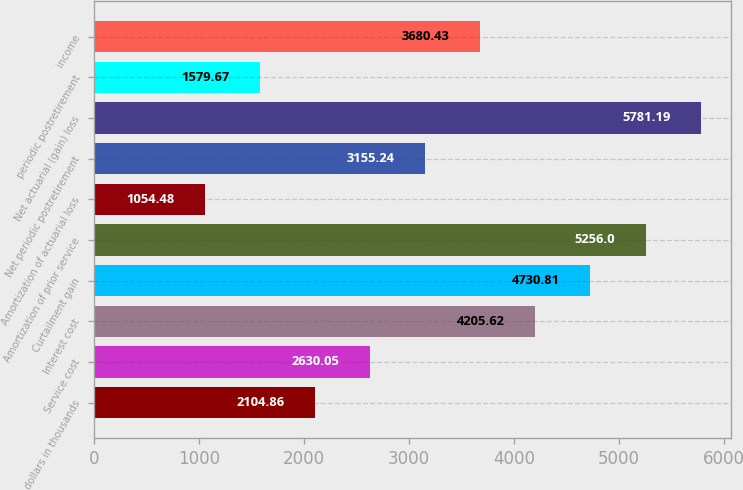Convert chart to OTSL. <chart><loc_0><loc_0><loc_500><loc_500><bar_chart><fcel>dollars in thousands<fcel>Service cost<fcel>Interest cost<fcel>Curtailment gain<fcel>Amortization of prior service<fcel>Amortization of actuarial loss<fcel>Net periodic postretirement<fcel>Net actuarial (gain) loss<fcel>periodic postretirement<fcel>income<nl><fcel>2104.86<fcel>2630.05<fcel>4205.62<fcel>4730.81<fcel>5256<fcel>1054.48<fcel>3155.24<fcel>5781.19<fcel>1579.67<fcel>3680.43<nl></chart> 